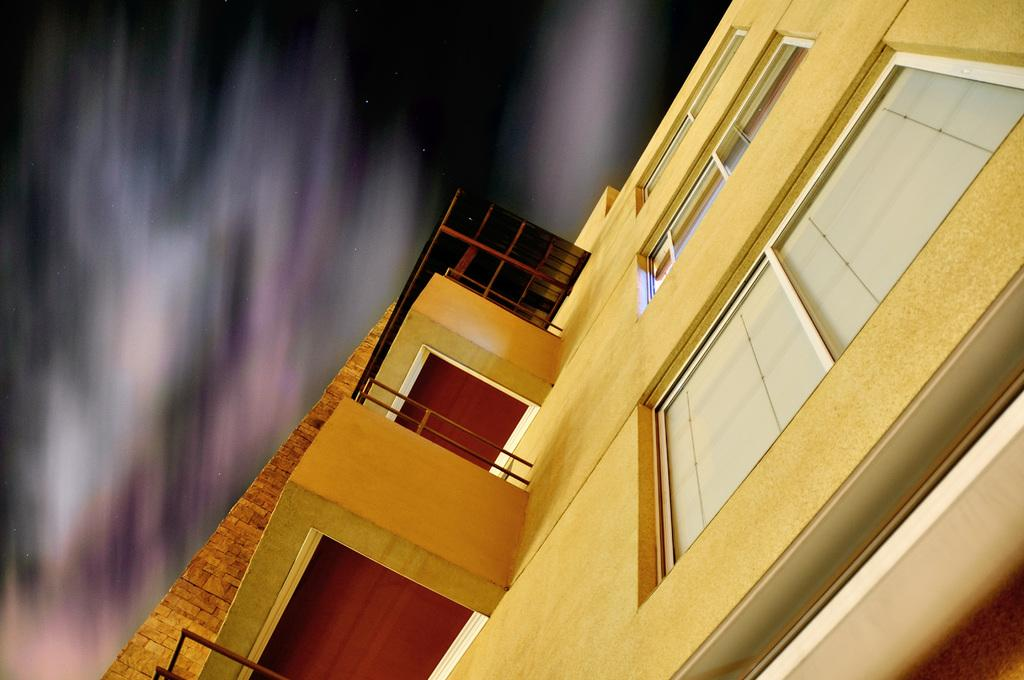What type of building is visible on the right side of the image? There is a building with glass windows on the right side of the image. Can you describe the background of the image? The background of the image is blurred. How many feet are visible in the image? There are no feet visible in the image. What type of turkey can be seen in the image? There is no turkey present in the image. 